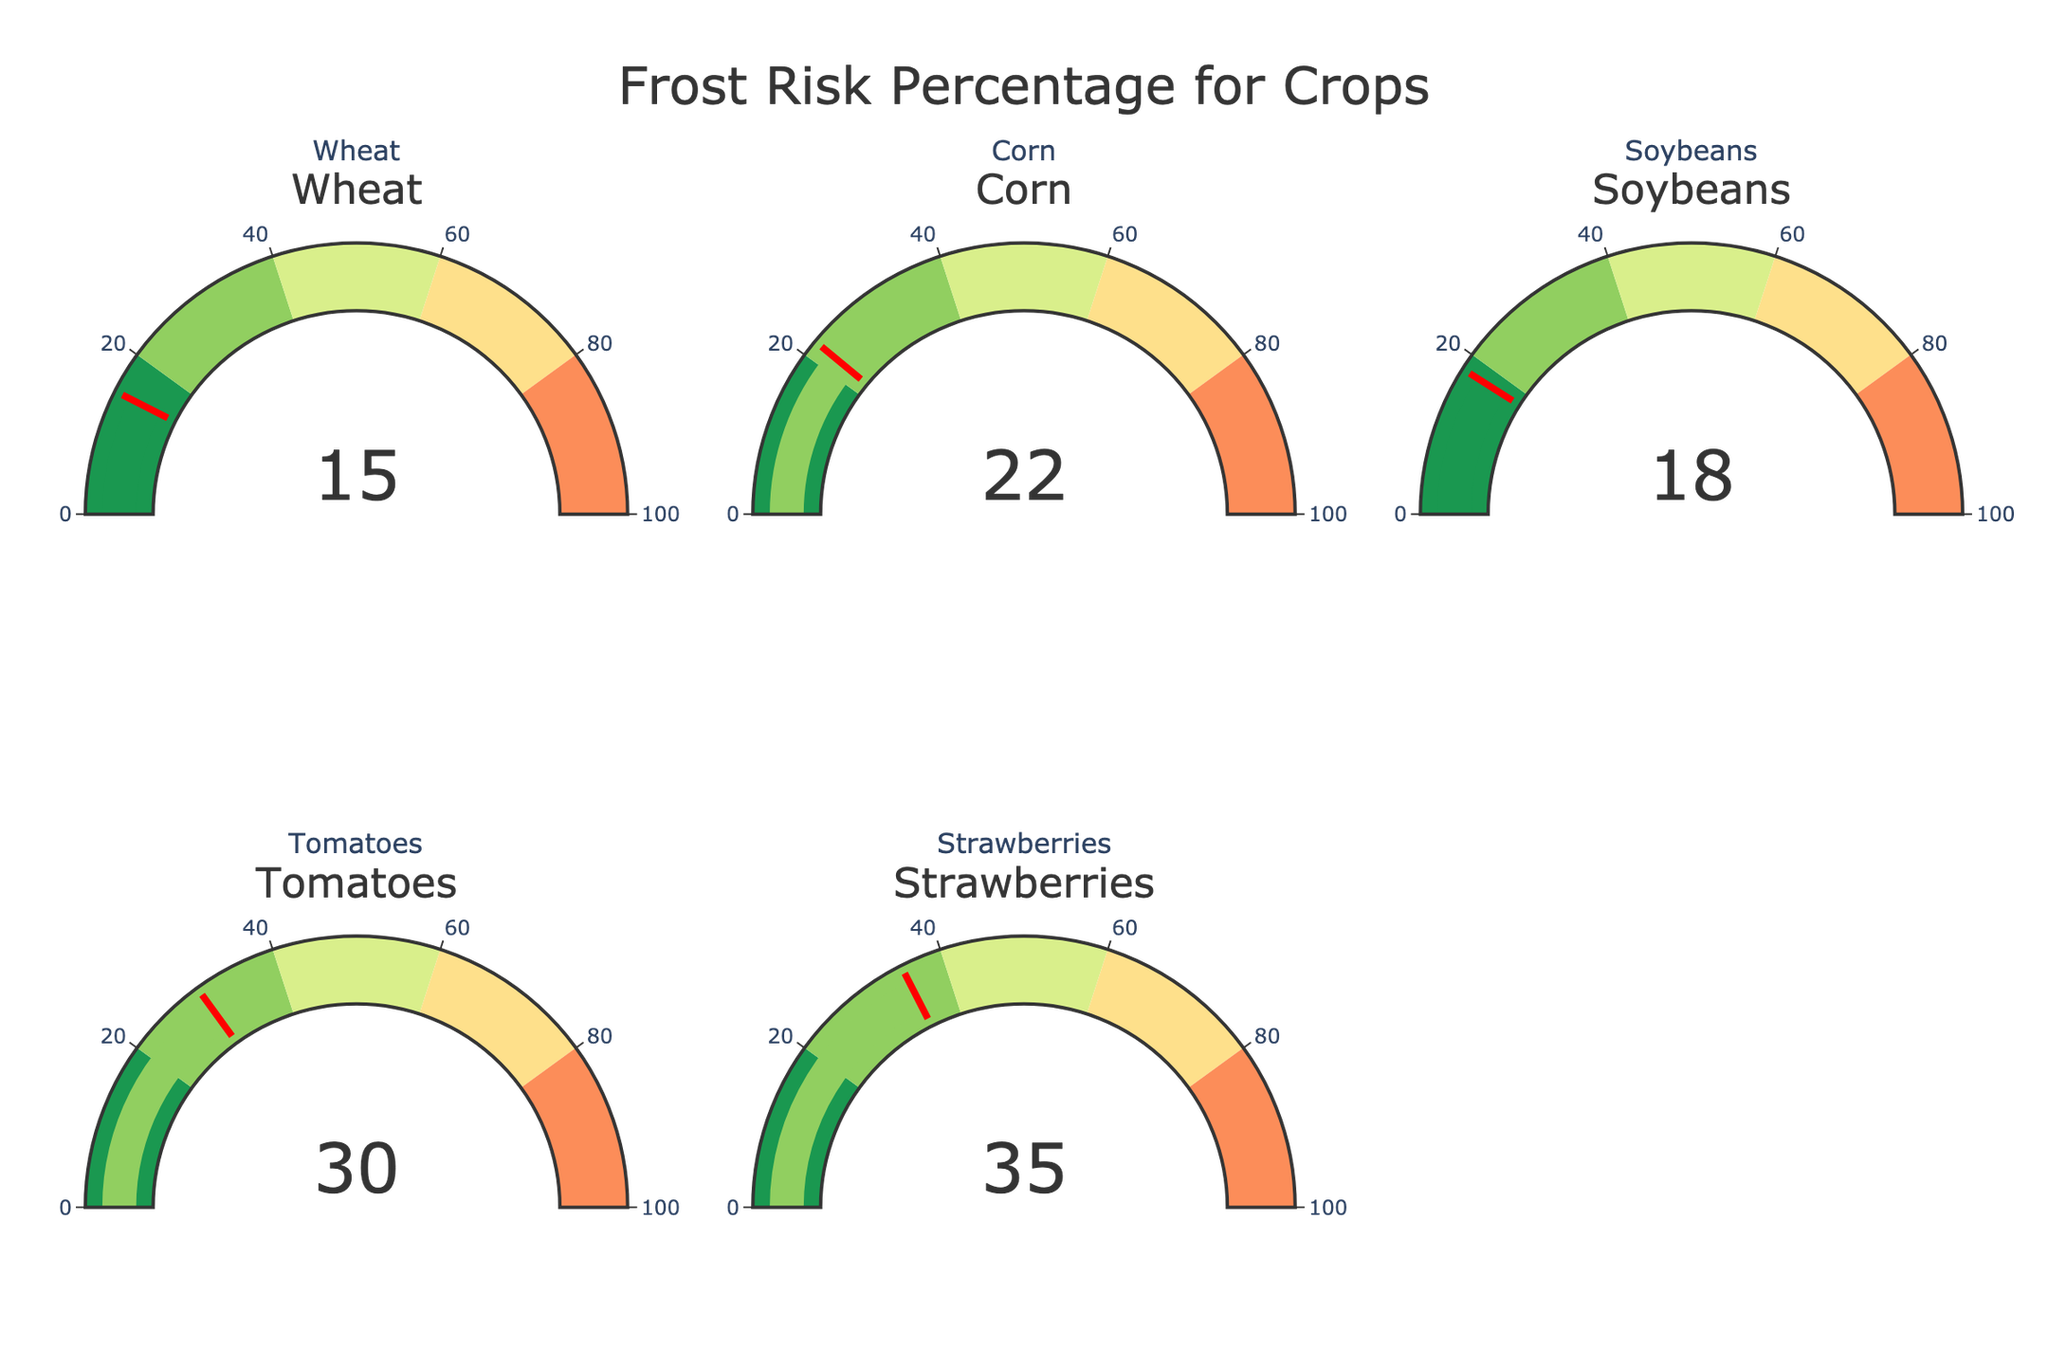Is the frost risk percentage for strawberries higher than that for wheat? The value for strawberries is 35%, and for wheat, it is 15%. Hence, 35% is greater than 15%.
Answer: Yes What is the combined frost risk percentage for corn and soybeans? The value for corn is 22% and for soybeans, it is 18%. Adding these gives 22 + 18 = 40
Answer: 40 Which crop has the lowest frost risk percentage? Looking at each value: Wheat (15%), Corn (22%), Soybeans (18%), Tomatoes (30%), Strawberries (35%). The lowest value here is for wheat.
Answer: Wheat How much higher is the frost risk percentage for tomatoes compared to soybeans? The value for tomatoes is 30% and for soybeans, it is 18%. The difference is 30 - 18 = 12
Answer: 12 What's the average frost risk percentage among all the crops? Summing the percentages: 15 + 22 + 18 + 30 + 35 = 120. There are 5 crops, so the average is 120 / 5 = 24
Answer: 24 What is the frost risk percentage for wheat? From the chart, the number displayed for wheat is 15%.
Answer: 15 Is the frost risk percentage for corn in the same range as that for strawberries? Corn has a frost risk percentage of 22%, which falls within the 20-40 range. Strawberries have 35%, also within the 20-40 range.
Answer: Yes Calculate the range of frost risk percentages among the crops. The highest percentage is for strawberries (35%) and the lowest is for wheat (15%). The range is 35 - 15 = 20
Answer: 20 Which crop has a frost risk percentage closest to 20%? Corn has 22% and soybeans have 18%. Soybeans are closer to 20% than corn.
Answer: Soybeans What percentage of crops have a frost risk percentage over 30%? Only tomatoes (30%) and strawberries (35%) have values over 30%. Therefore, 2 out of 5 crops fit this criterion. This makes 2/5 or 40%.
Answer: 40% 